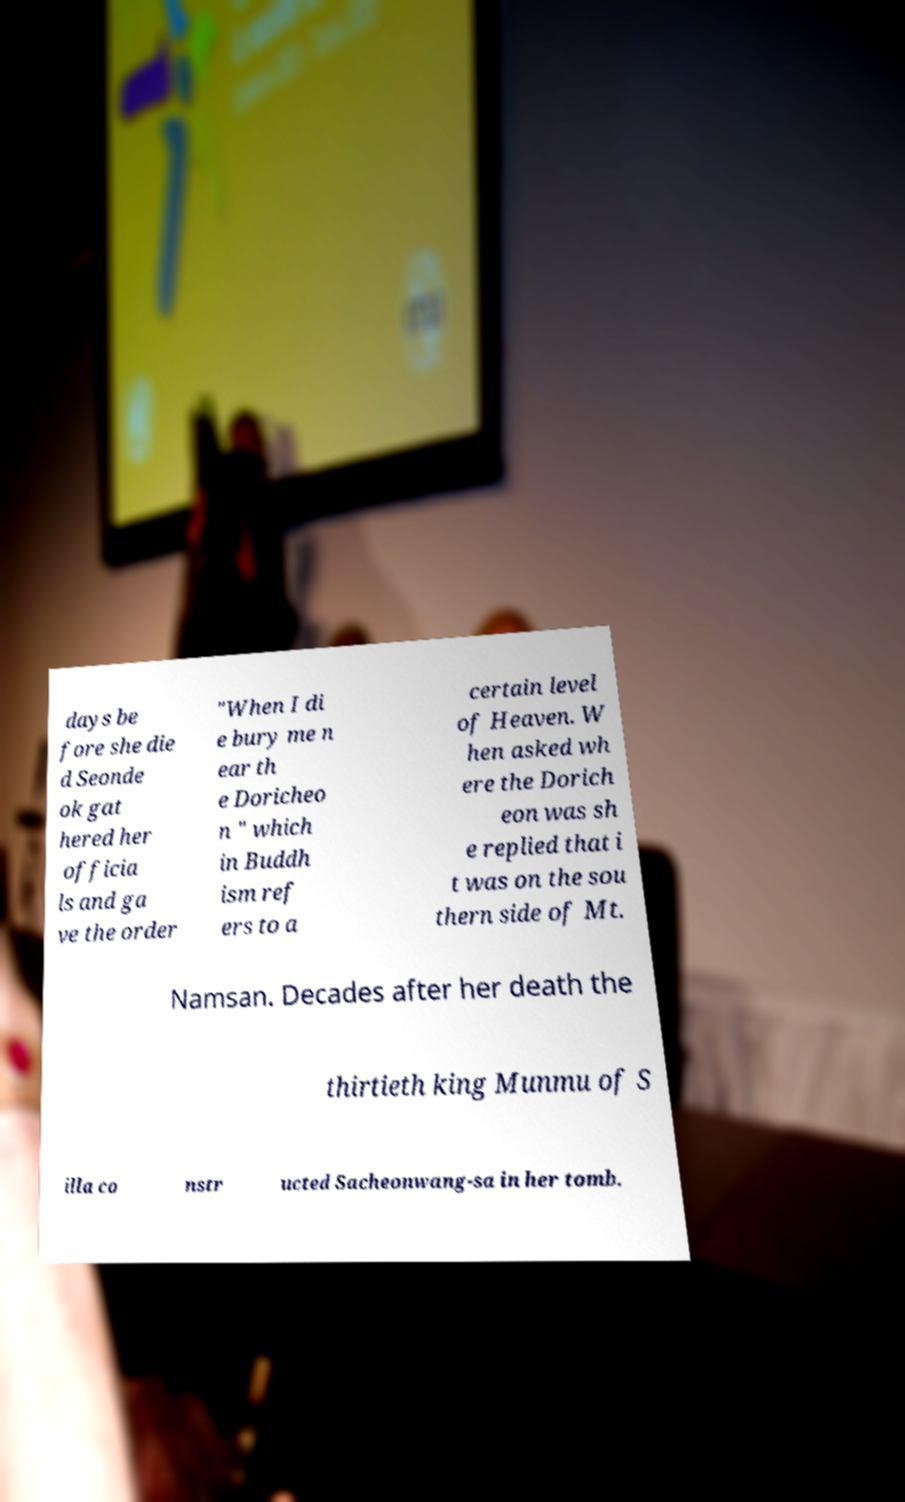There's text embedded in this image that I need extracted. Can you transcribe it verbatim? days be fore she die d Seonde ok gat hered her officia ls and ga ve the order "When I di e bury me n ear th e Doricheo n " which in Buddh ism ref ers to a certain level of Heaven. W hen asked wh ere the Dorich eon was sh e replied that i t was on the sou thern side of Mt. Namsan. Decades after her death the thirtieth king Munmu of S illa co nstr ucted Sacheonwang-sa in her tomb. 